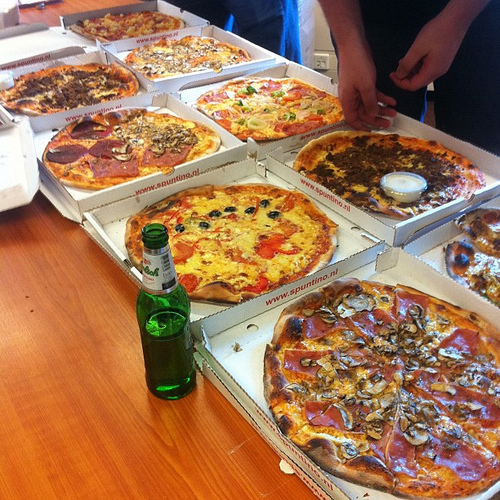Do you see any boxes to the right of the mushrooms that are in the top? Yes, there are boxes to the right of the mushrooms that are in the top. 